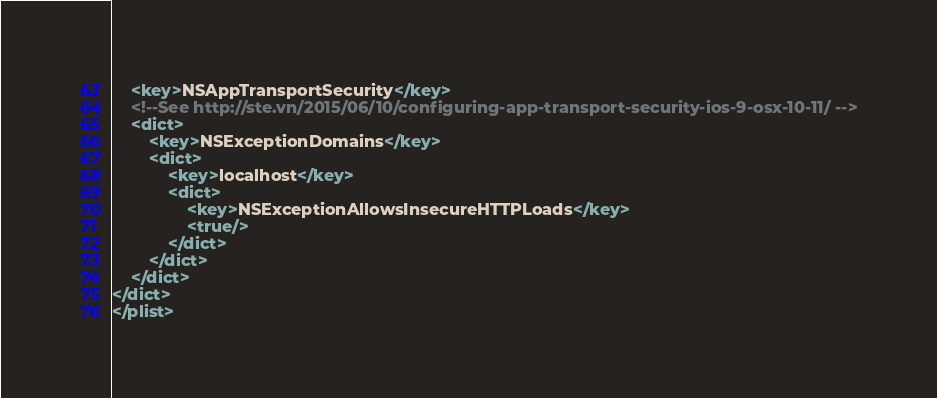Convert code to text. <code><loc_0><loc_0><loc_500><loc_500><_XML_>	<key>NSAppTransportSecurity</key>
	<!--See http://ste.vn/2015/06/10/configuring-app-transport-security-ios-9-osx-10-11/ -->
	<dict>
		<key>NSExceptionDomains</key>
		<dict>
			<key>localhost</key>
			<dict>
				<key>NSExceptionAllowsInsecureHTTPLoads</key>
				<true/>
			</dict>
		</dict>
	</dict>
</dict>
</plist>
</code> 